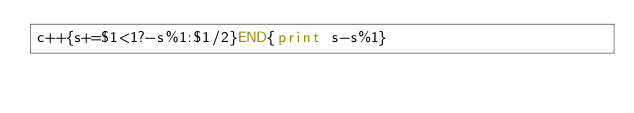Convert code to text. <code><loc_0><loc_0><loc_500><loc_500><_Awk_>c++{s+=$1<1?-s%1:$1/2}END{print s-s%1}</code> 